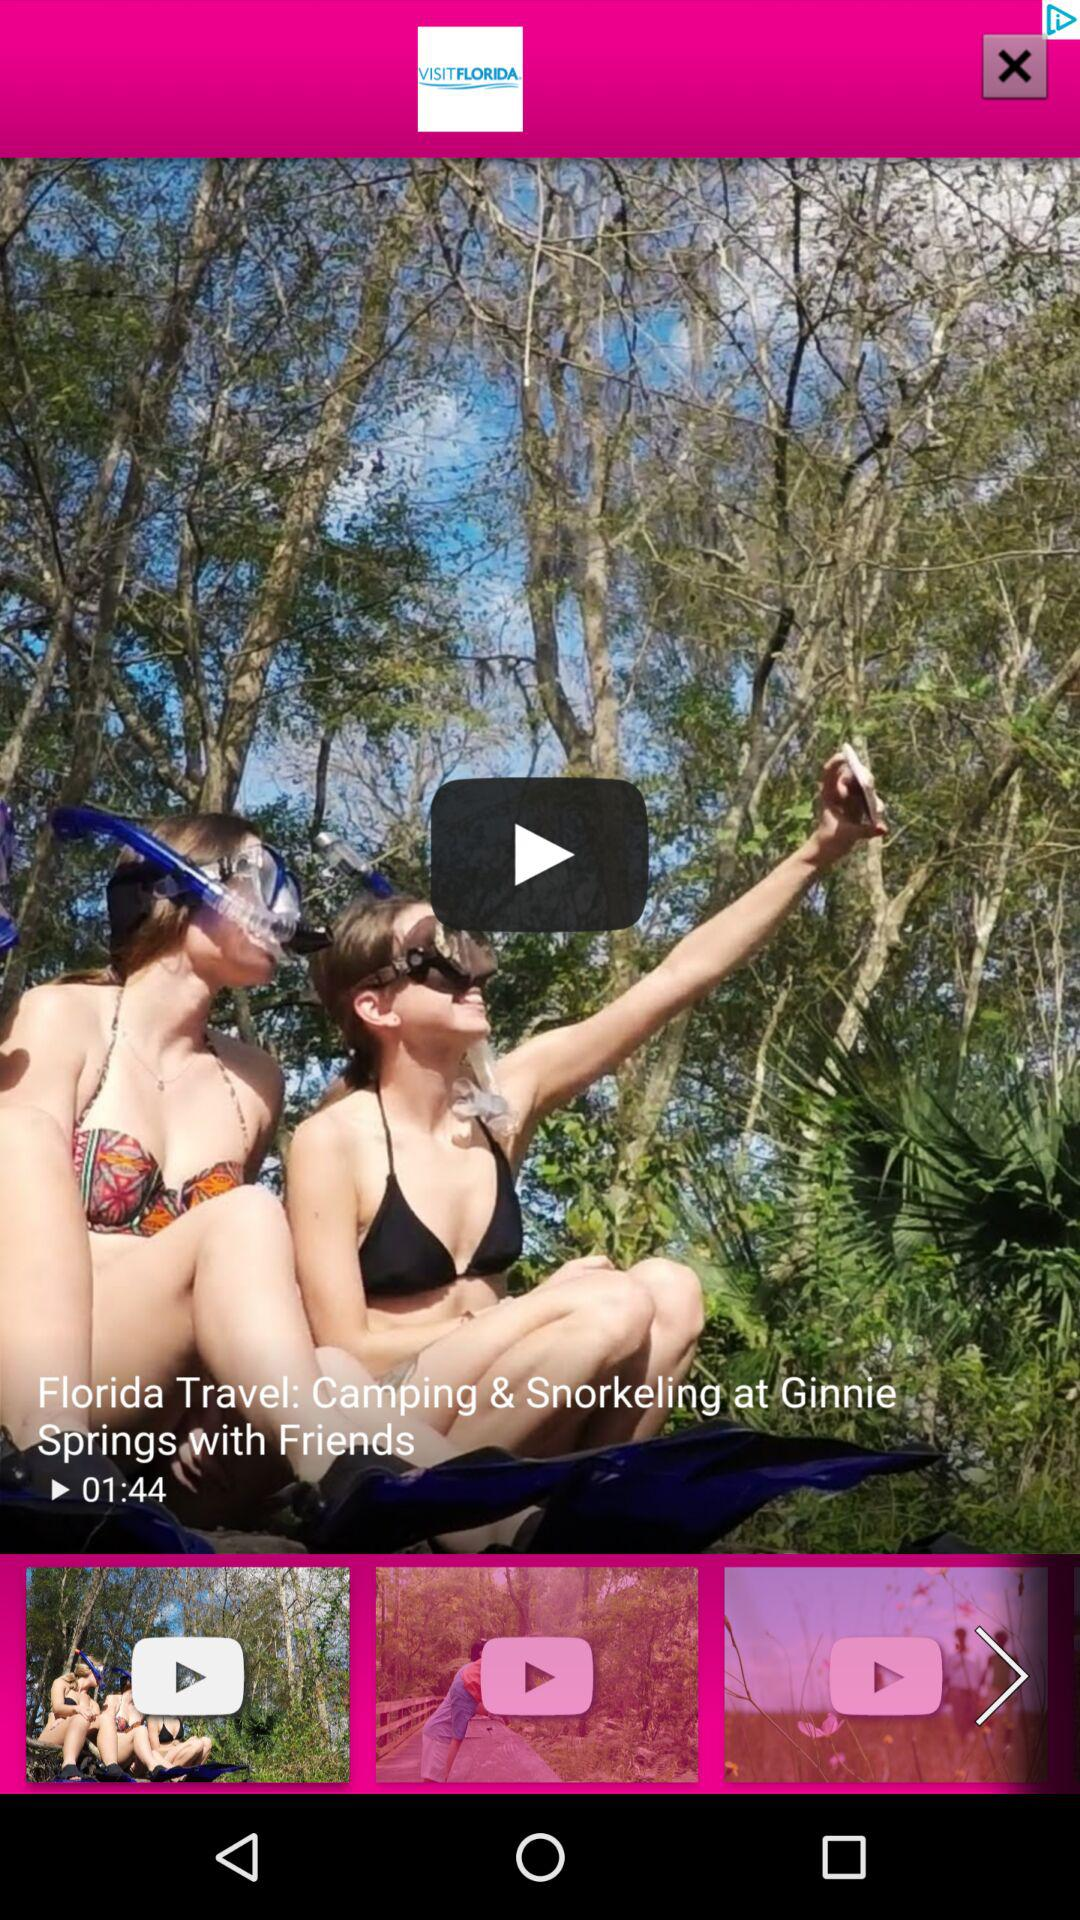What's the title of the video? The title of the video is "Florida Travel: Camping & Snorkeling at Ginnie Springs with Friends". 